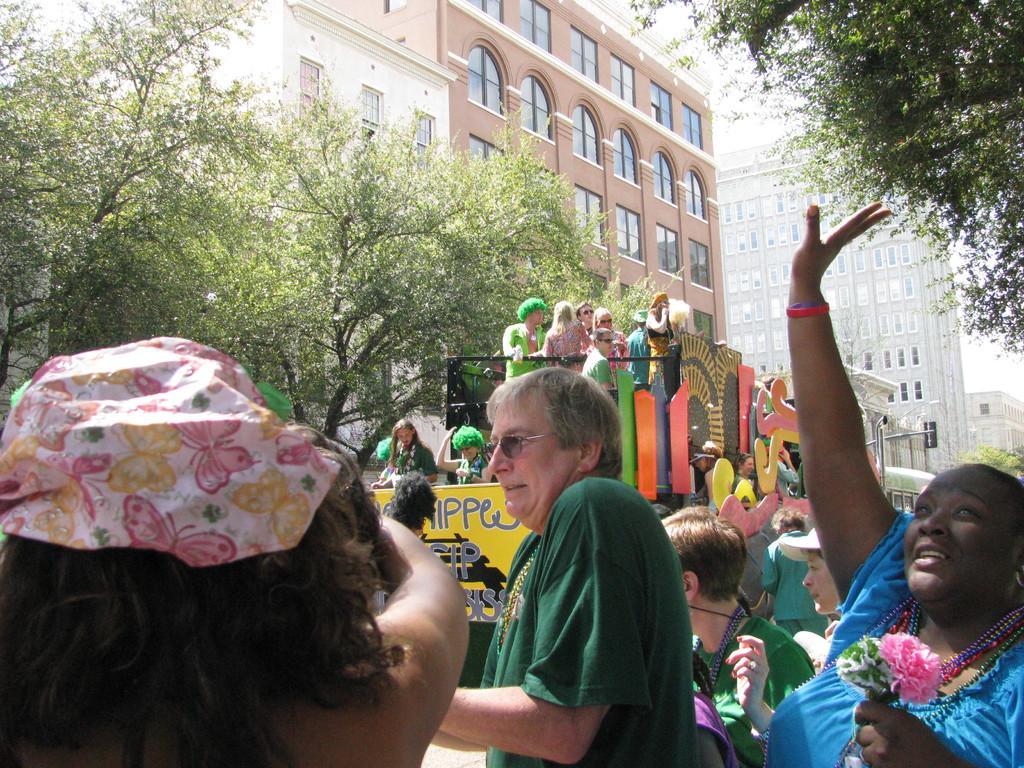How would you summarize this image in a sentence or two? In this image we can see people standing and there is a vehicle. We can see people in the vehicle. In the background there are trees, buildings and sky. 